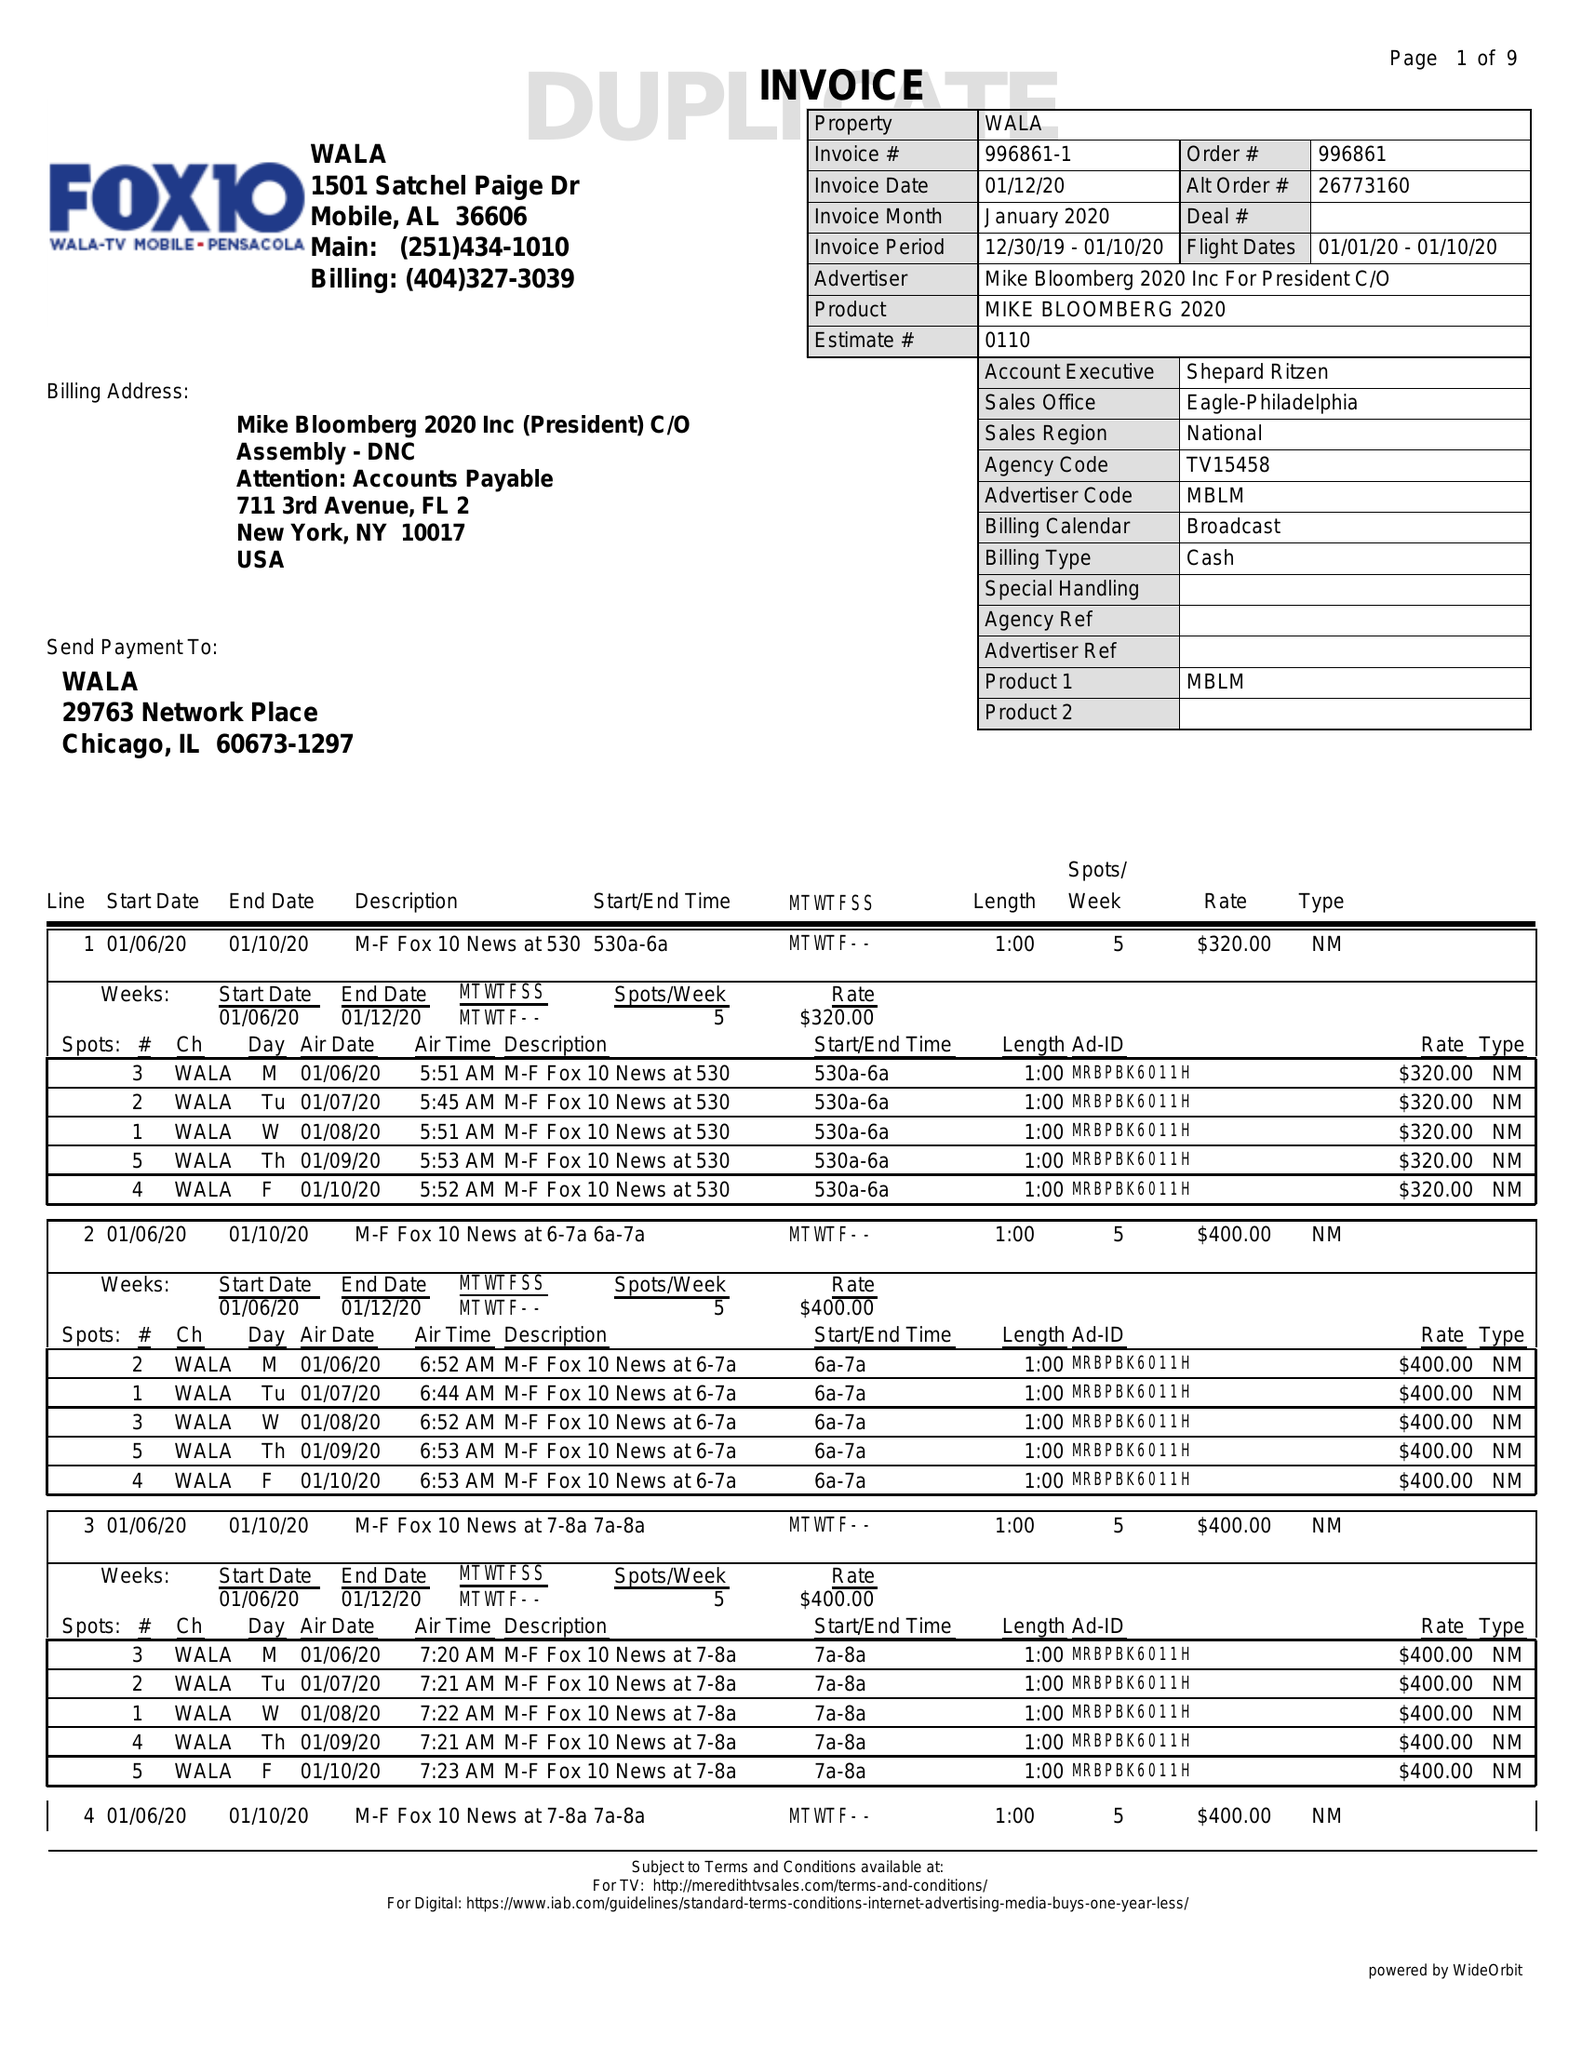What is the value for the advertiser?
Answer the question using a single word or phrase. MIKEBLOOMBERG2020INCFORPRESIDENTC/O 